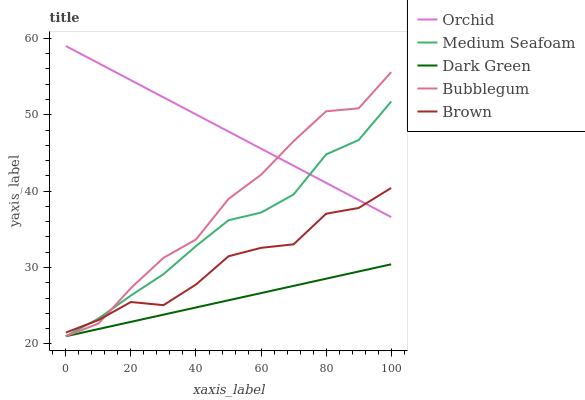Does Dark Green have the minimum area under the curve?
Answer yes or no. Yes. Does Orchid have the maximum area under the curve?
Answer yes or no. Yes. Does Medium Seafoam have the minimum area under the curve?
Answer yes or no. No. Does Medium Seafoam have the maximum area under the curve?
Answer yes or no. No. Is Dark Green the smoothest?
Answer yes or no. Yes. Is Bubblegum the roughest?
Answer yes or no. Yes. Is Medium Seafoam the smoothest?
Answer yes or no. No. Is Medium Seafoam the roughest?
Answer yes or no. No. Does Orchid have the lowest value?
Answer yes or no. No. Does Orchid have the highest value?
Answer yes or no. Yes. Does Medium Seafoam have the highest value?
Answer yes or no. No. Is Dark Green less than Brown?
Answer yes or no. Yes. Is Orchid greater than Dark Green?
Answer yes or no. Yes. Does Dark Green intersect Brown?
Answer yes or no. No. 